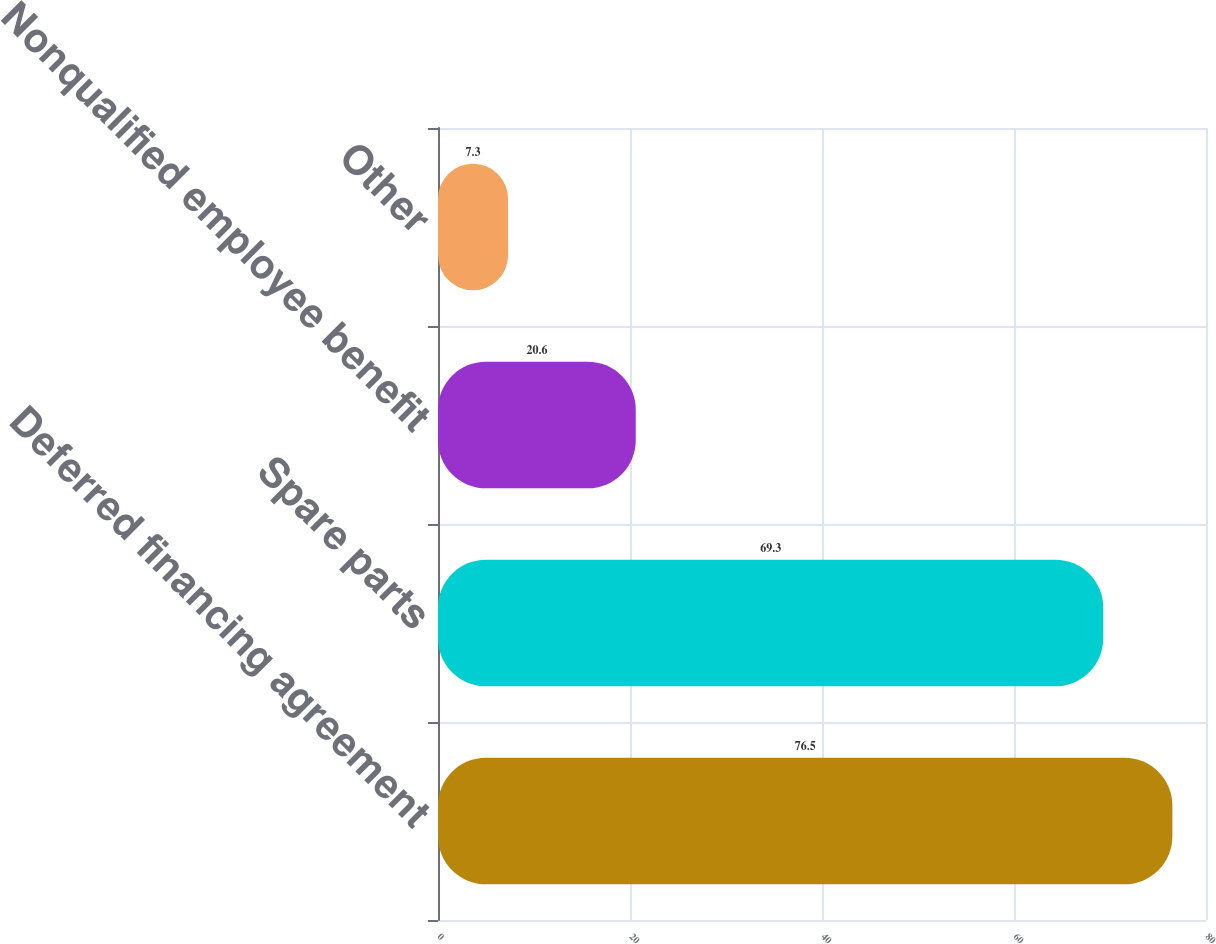Convert chart to OTSL. <chart><loc_0><loc_0><loc_500><loc_500><bar_chart><fcel>Deferred financing agreement<fcel>Spare parts<fcel>Nonqualified employee benefit<fcel>Other<nl><fcel>76.5<fcel>69.3<fcel>20.6<fcel>7.3<nl></chart> 